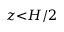<formula> <loc_0><loc_0><loc_500><loc_500>z { < } H / 2</formula> 